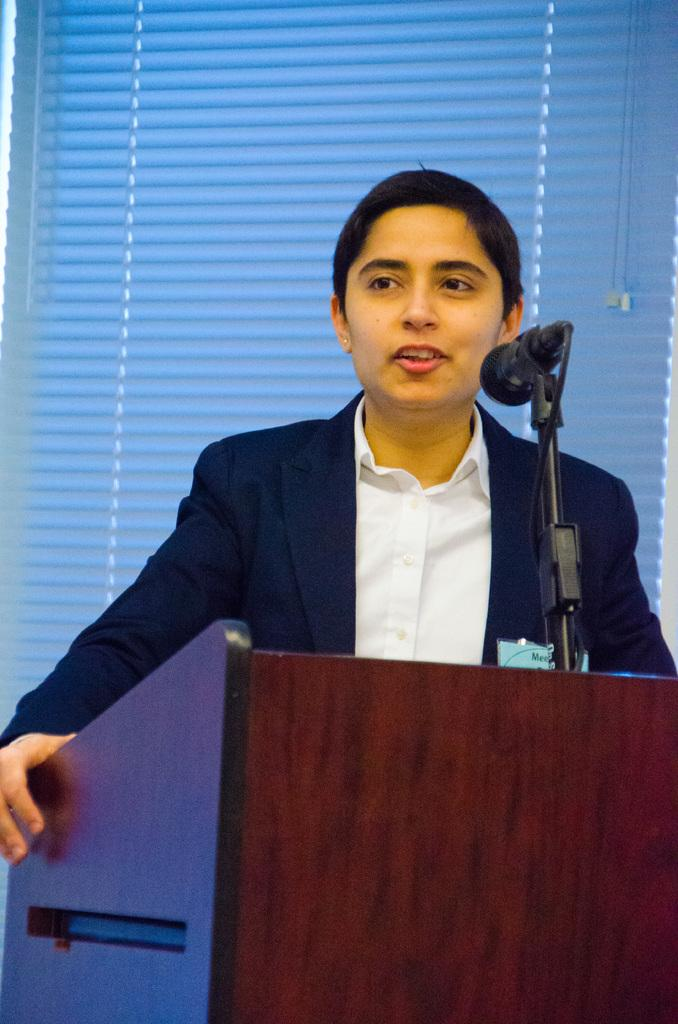What is the person in the image doing? There is a person talking in the image. Can you describe the person's position in relation to the other person? There is another person in front of the person talking. What object is present that might be used for amplifying the person's voice? There is a microphone in the image. What type of window covering is visible in the image? There is a window curtain in the image. What type of toy can be seen on the table in the image? There is no toy present in the image. What type of silk fabric is being traded in the image? There is no silk or trade activity depicted in the image. 